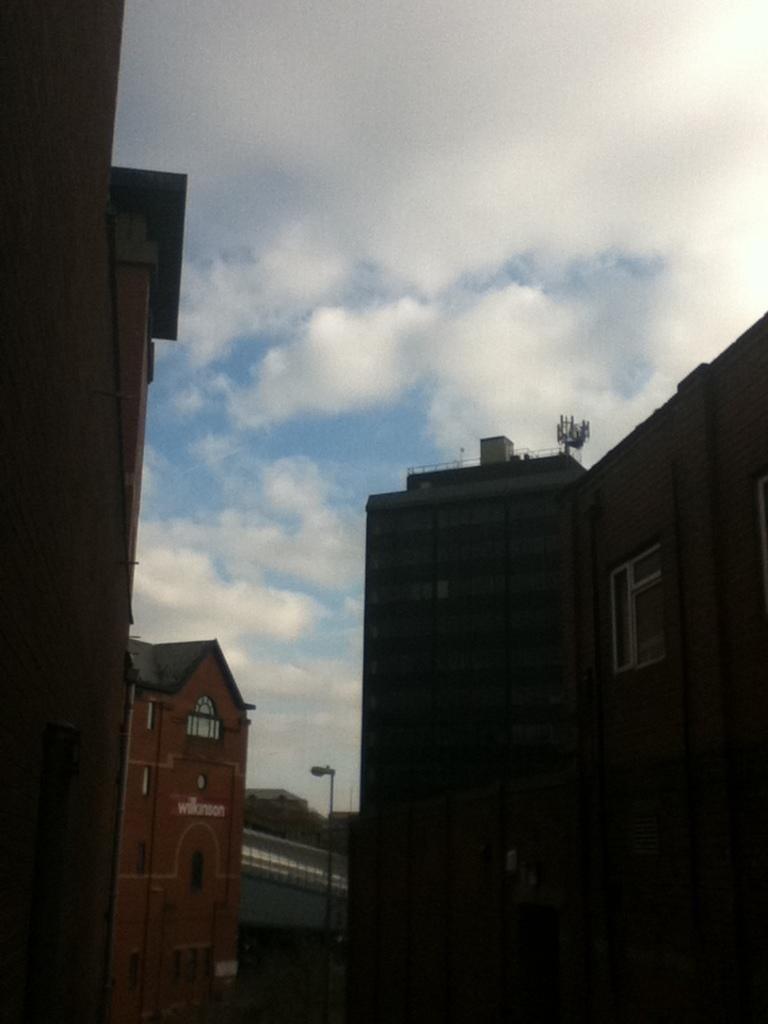What type of structures can be seen in the image? There are buildings in the image. What can be seen illuminating the area in the image? Street lights are visible in the image. What is visible in the sky in the image? Clouds are present in the sky in the image. What type of zipper can be seen on the buildings in the image? There are no zippers present on the buildings in the image. Can you provide an example of a building in the image? Since the image is not provided, it is not possible to give an example of a building in the image. 